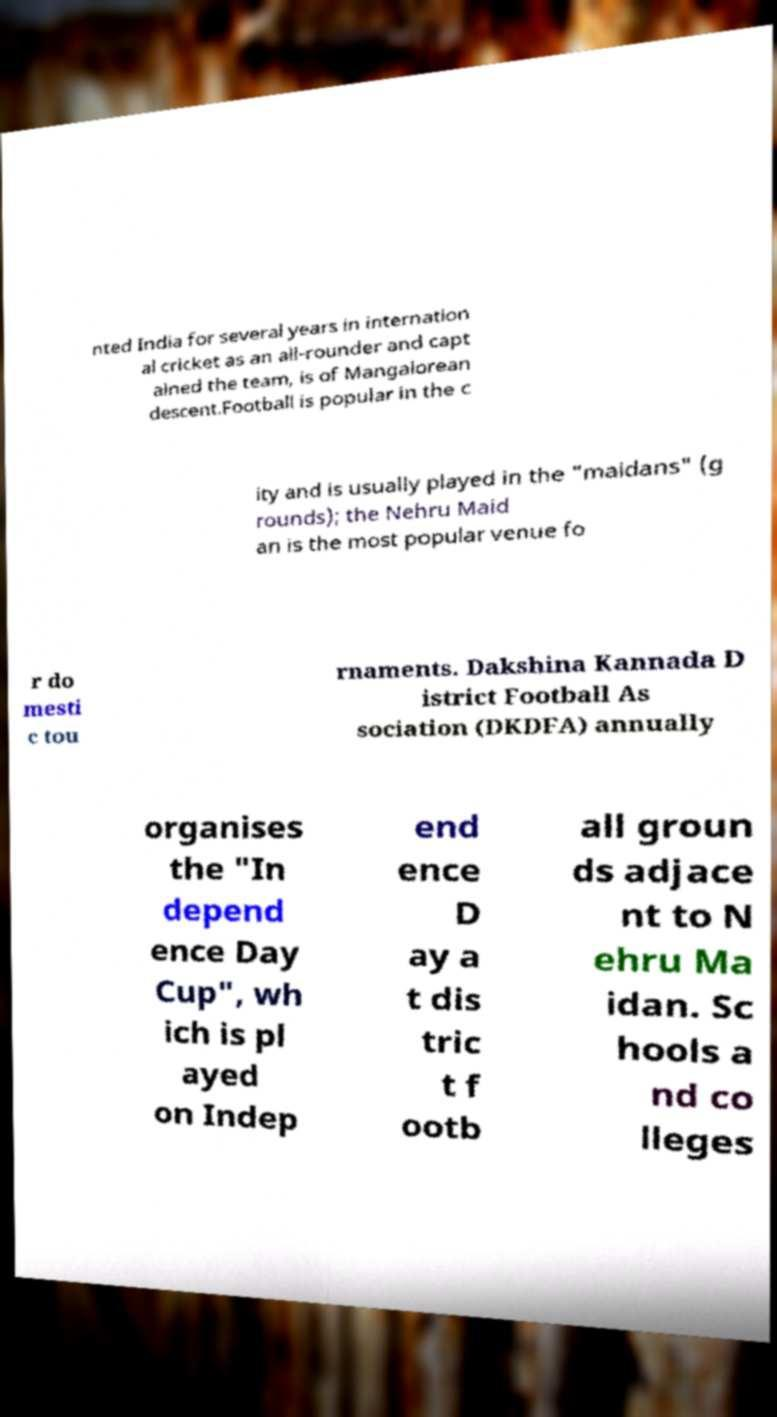What messages or text are displayed in this image? I need them in a readable, typed format. nted India for several years in internation al cricket as an all-rounder and capt ained the team, is of Mangalorean descent.Football is popular in the c ity and is usually played in the "maidans" (g rounds); the Nehru Maid an is the most popular venue fo r do mesti c tou rnaments. Dakshina Kannada D istrict Football As sociation (DKDFA) annually organises the "In depend ence Day Cup", wh ich is pl ayed on Indep end ence D ay a t dis tric t f ootb all groun ds adjace nt to N ehru Ma idan. Sc hools a nd co lleges 